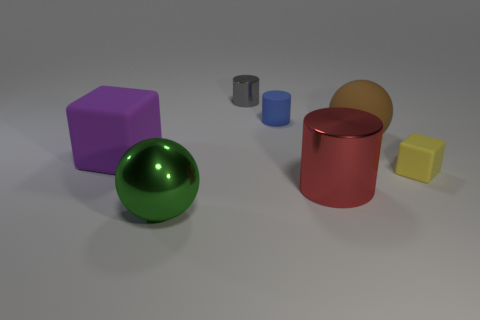Add 2 cyan metal blocks. How many objects exist? 9 Subtract all cubes. How many objects are left? 5 Add 2 purple rubber objects. How many purple rubber objects are left? 3 Add 3 large green balls. How many large green balls exist? 4 Subtract 0 brown blocks. How many objects are left? 7 Subtract all yellow blocks. Subtract all tiny gray things. How many objects are left? 5 